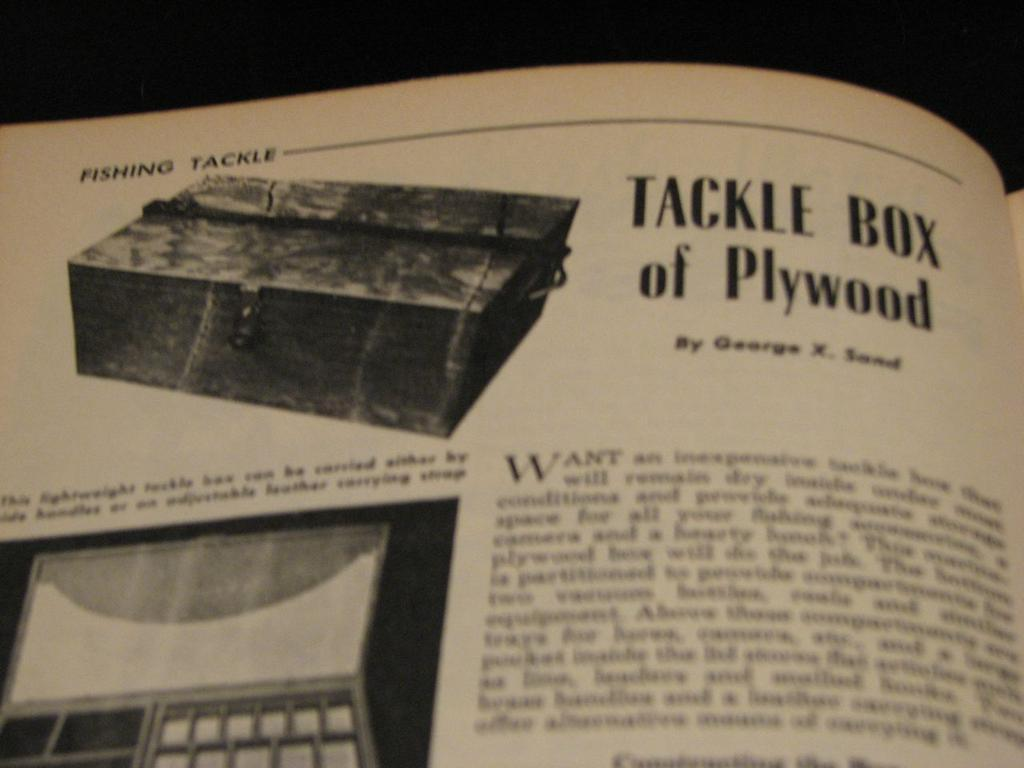What is depicted on the paper in the image? There is a paper of a book in the image. What can be seen on the paper besides the book? The paper has images on it, and there is writing beside and below the images. What type of substance is being played with on the playground in the image? There is no playground or substance present in the image; it features a paper of a book with images and writing. 